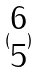<formula> <loc_0><loc_0><loc_500><loc_500>( \begin{matrix} 6 \\ 5 \end{matrix} )</formula> 